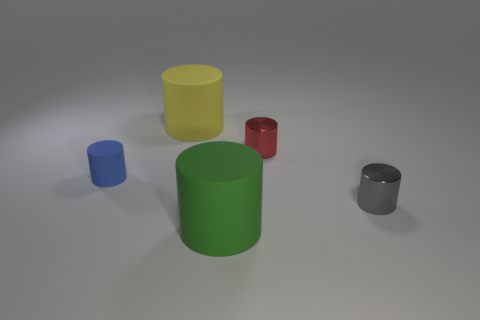Subtract all gray cylinders. How many cylinders are left? 4 Subtract all tiny red cylinders. How many cylinders are left? 4 Subtract 1 cylinders. How many cylinders are left? 4 Subtract all cyan cylinders. Subtract all gray cubes. How many cylinders are left? 5 Add 1 tiny cyan metallic blocks. How many objects exist? 6 Add 4 metal things. How many metal things exist? 6 Subtract 0 brown cylinders. How many objects are left? 5 Subtract all small brown rubber spheres. Subtract all tiny gray cylinders. How many objects are left? 4 Add 5 tiny cylinders. How many tiny cylinders are left? 8 